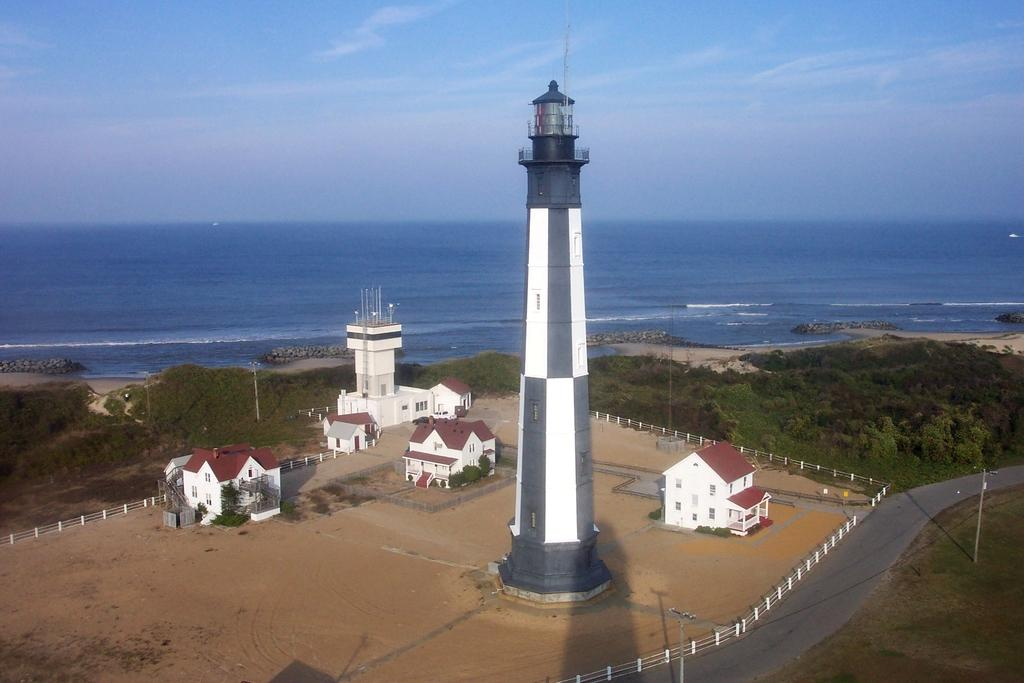What is located in the center of the image? Buildings, trees, poles, a tower, a wall, roofs, a fence, and a road are all located in the center of the image. What type of vegetation is present in the center of the image? Trees are present in the center of the image. What architectural features can be seen in the center of the image? Buildings, a tower, a wall, roofs, and a fence are all architectural features visible in the center of the image. What is visible on the ground in the center of the image? Grass and the ground are visible in the center of the image. What can be seen in the background of the image? The sky, clouds, and water are visible in the background of the image. Can you hear the fan spinning in the image? There is no fan present in the image, so it cannot be heard spinning. What type of star is visible in the image? There are no stars visible in the image; it features a landscape with buildings, trees, and other structures. 